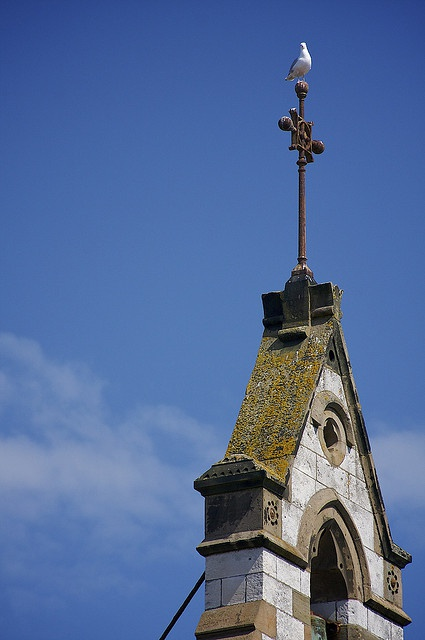Describe the objects in this image and their specific colors. I can see a bird in darkblue, gray, white, and darkgray tones in this image. 